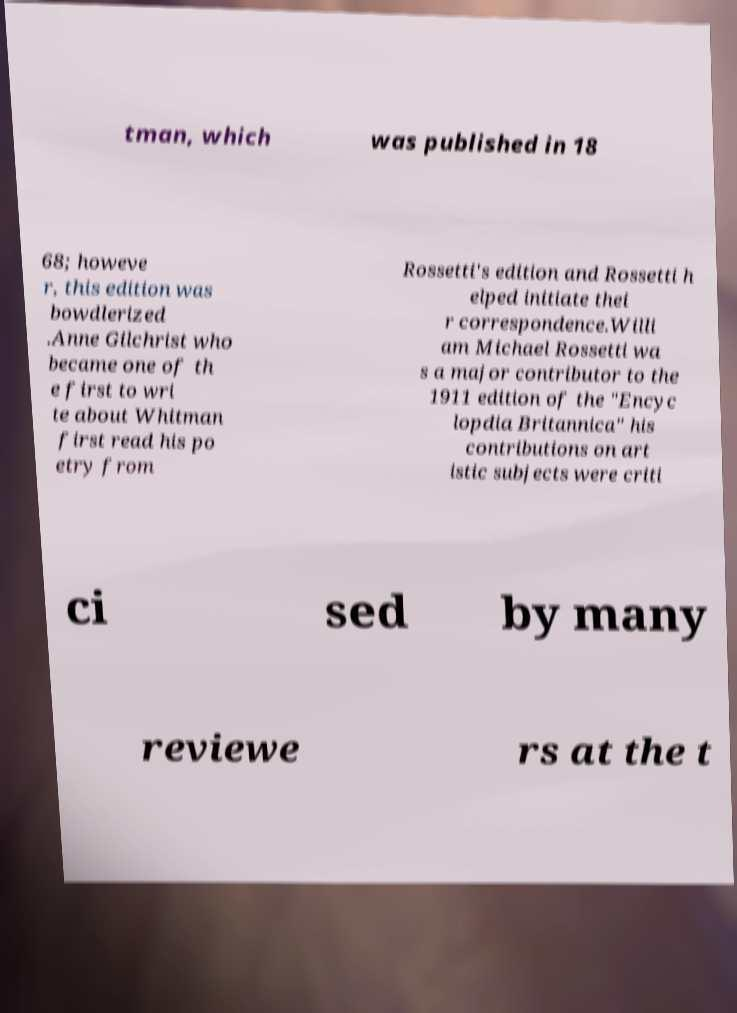Can you read and provide the text displayed in the image?This photo seems to have some interesting text. Can you extract and type it out for me? tman, which was published in 18 68; howeve r, this edition was bowdlerized .Anne Gilchrist who became one of th e first to wri te about Whitman first read his po etry from Rossetti's edition and Rossetti h elped initiate thei r correspondence.Willi am Michael Rossetti wa s a major contributor to the 1911 edition of the "Encyc lopdia Britannica" his contributions on art istic subjects were criti ci sed by many reviewe rs at the t 